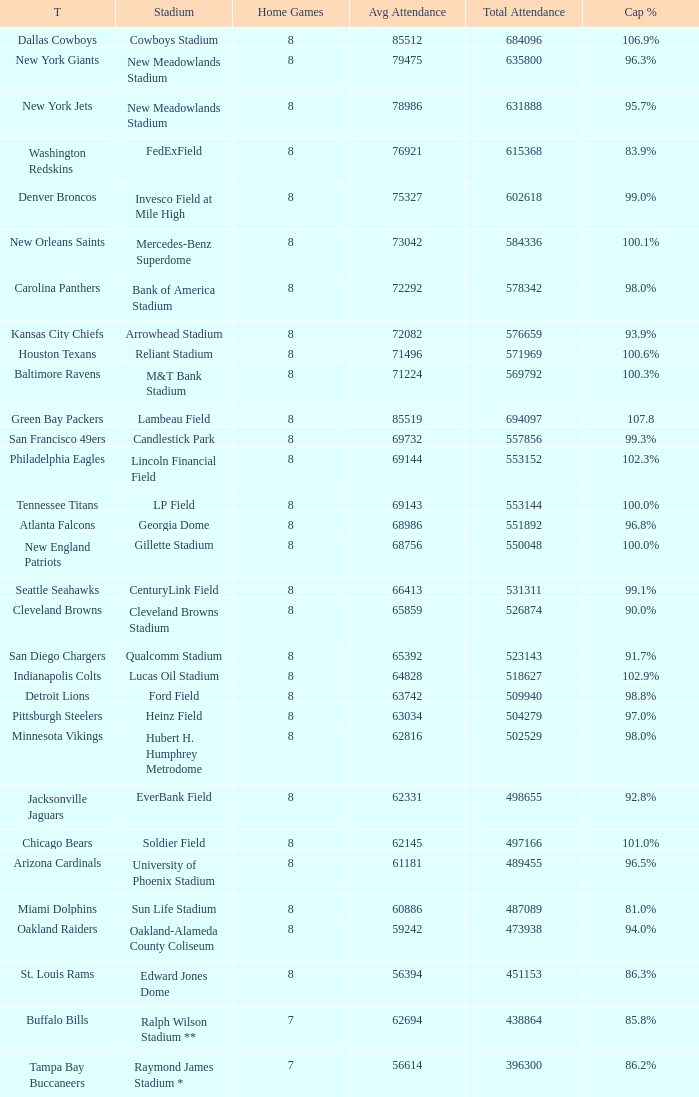What is the number listed in home games when the team is Seattle Seahawks? 8.0. 